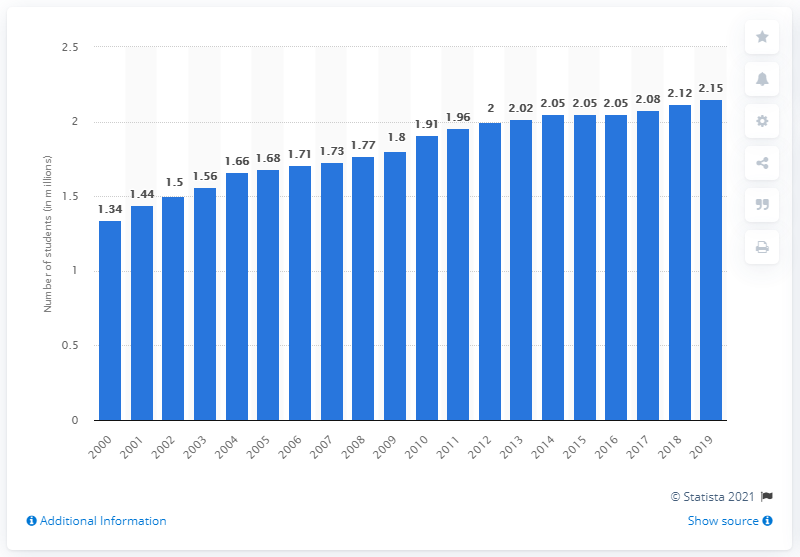Highlight a few significant elements in this photo. In 2019, there were approximately 2.15 million students enrolled in postsecondary institutions in Canada. 